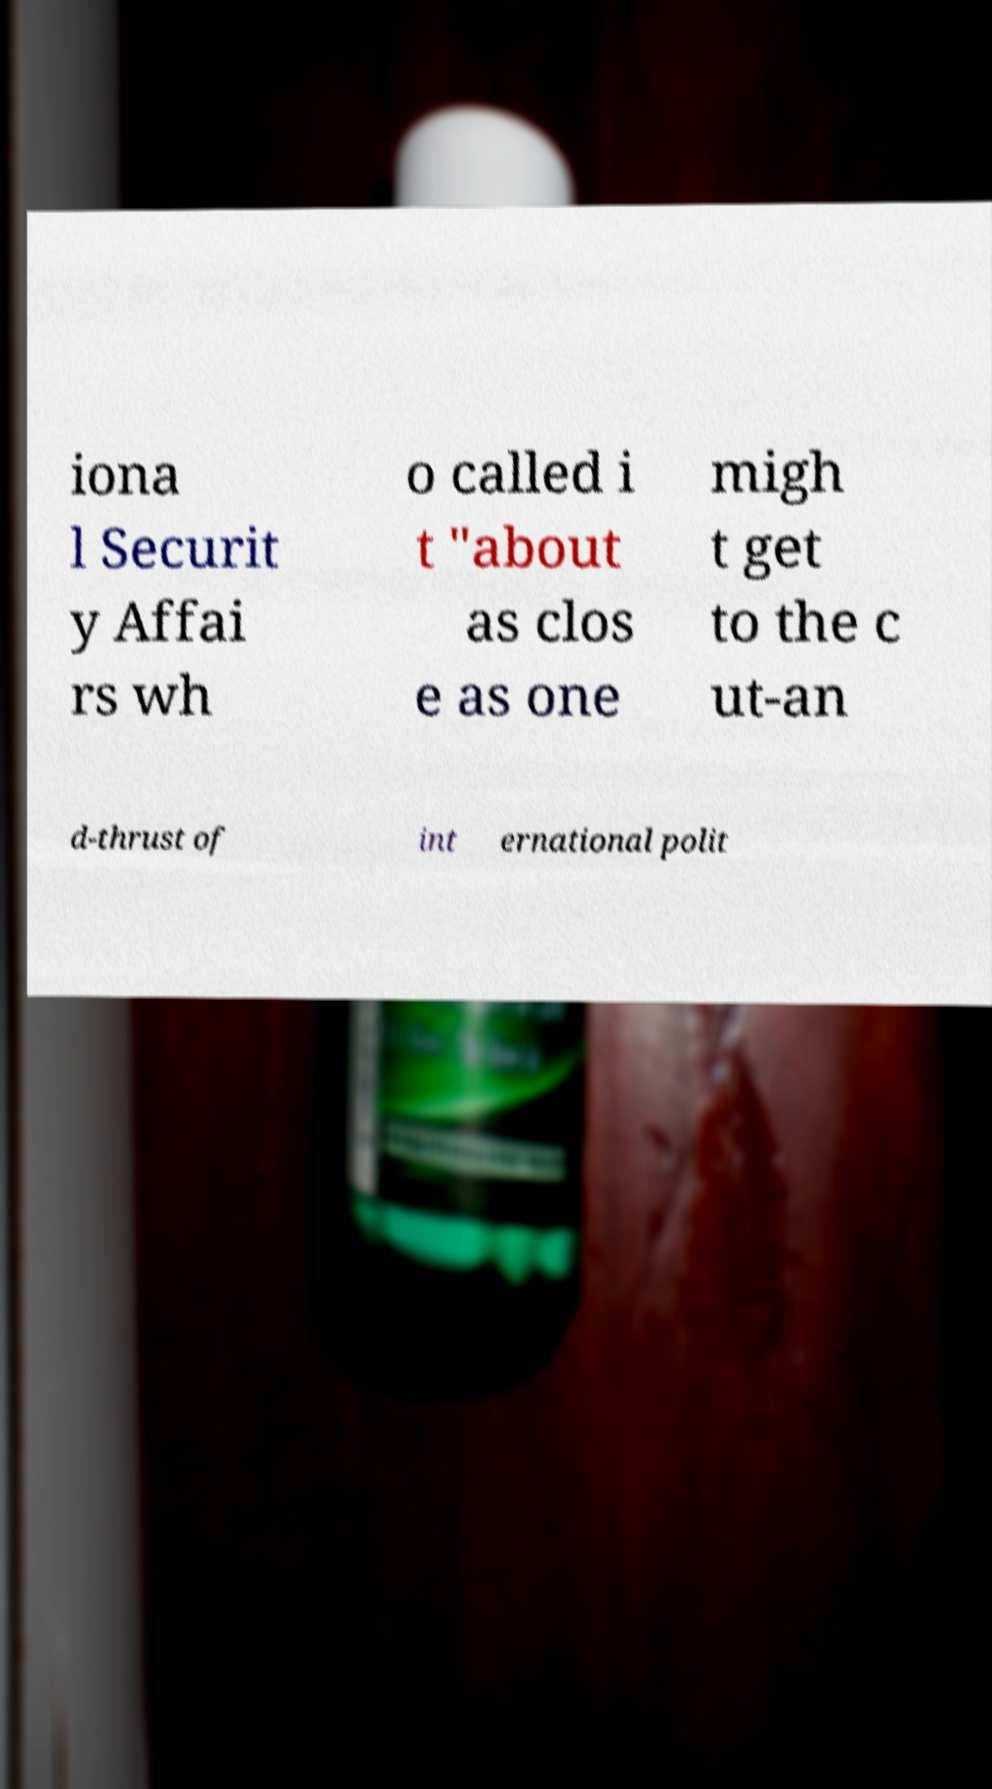Please read and relay the text visible in this image. What does it say? iona l Securit y Affai rs wh o called i t "about as clos e as one migh t get to the c ut-an d-thrust of int ernational polit 